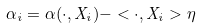Convert formula to latex. <formula><loc_0><loc_0><loc_500><loc_500>\alpha _ { i } = \alpha ( \cdot , X _ { i } ) - < \cdot , X _ { i } > \eta</formula> 